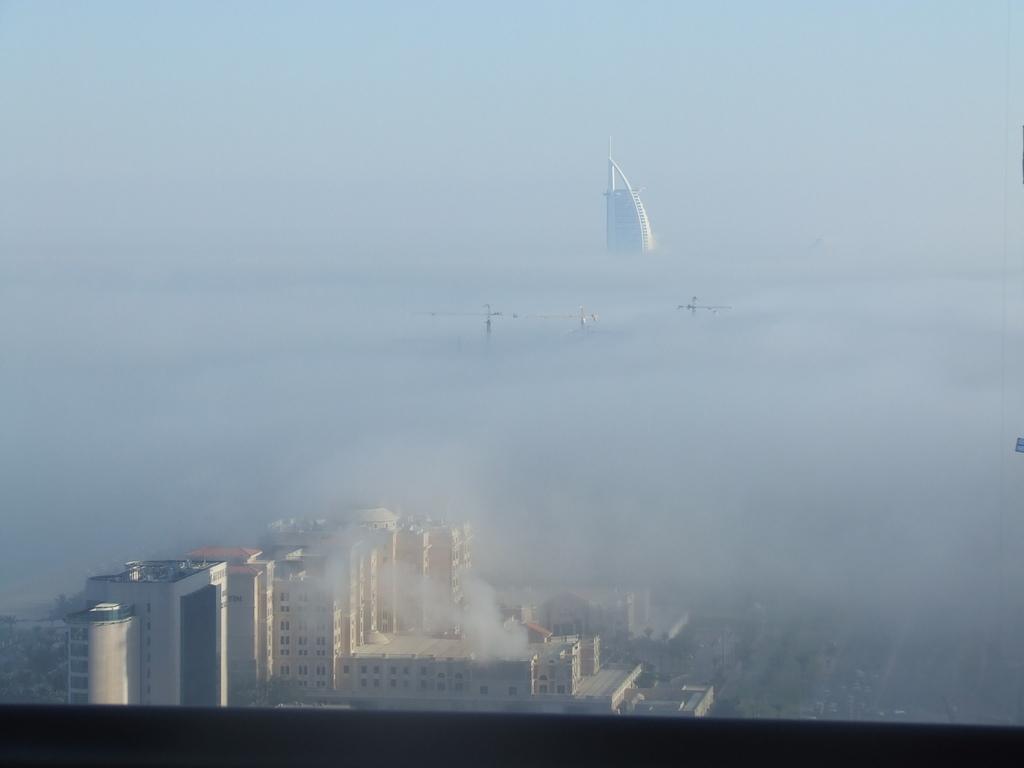Please provide a concise description of this image. This is the picture of a city. In this image there are buildings. At the back the building is covered with fog. At the top there is sky. At the bottom there are vehicles on the road. 